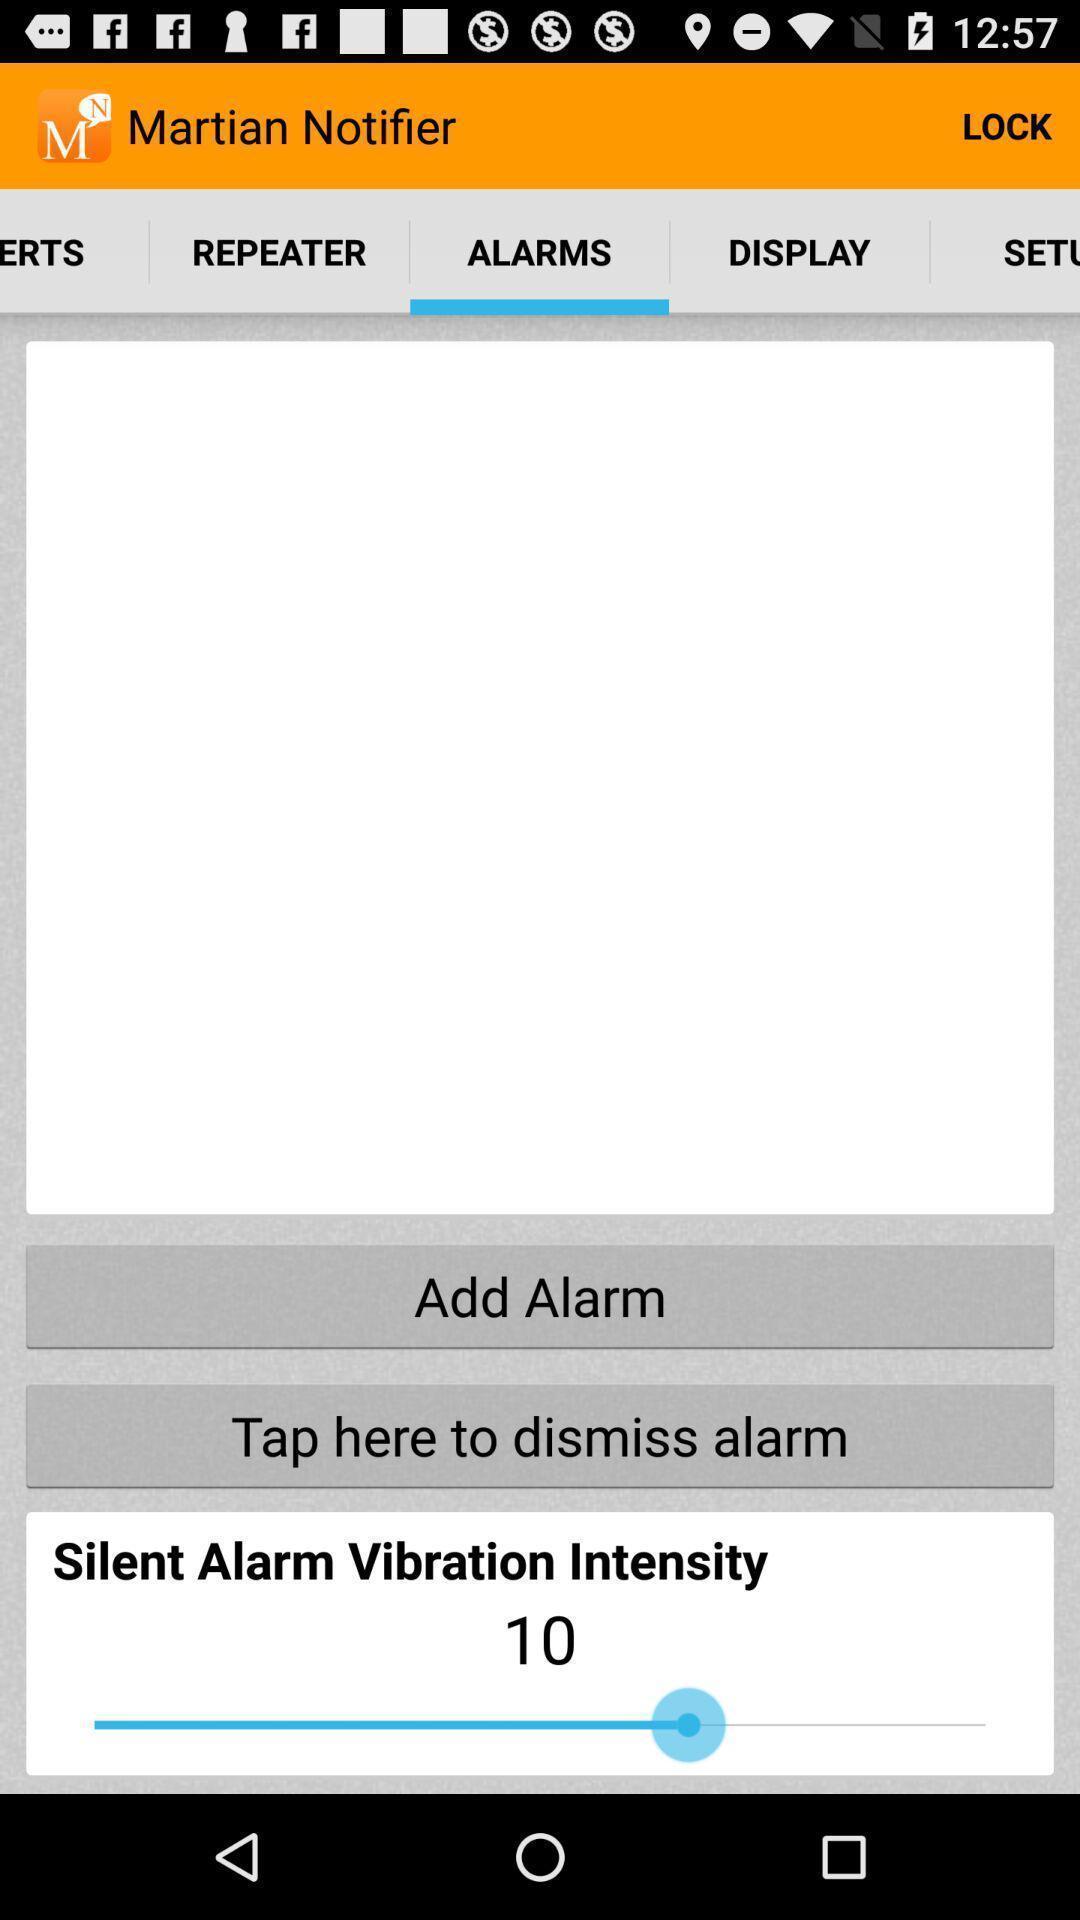Provide a textual representation of this image. Page displaying settings options for alarm. 